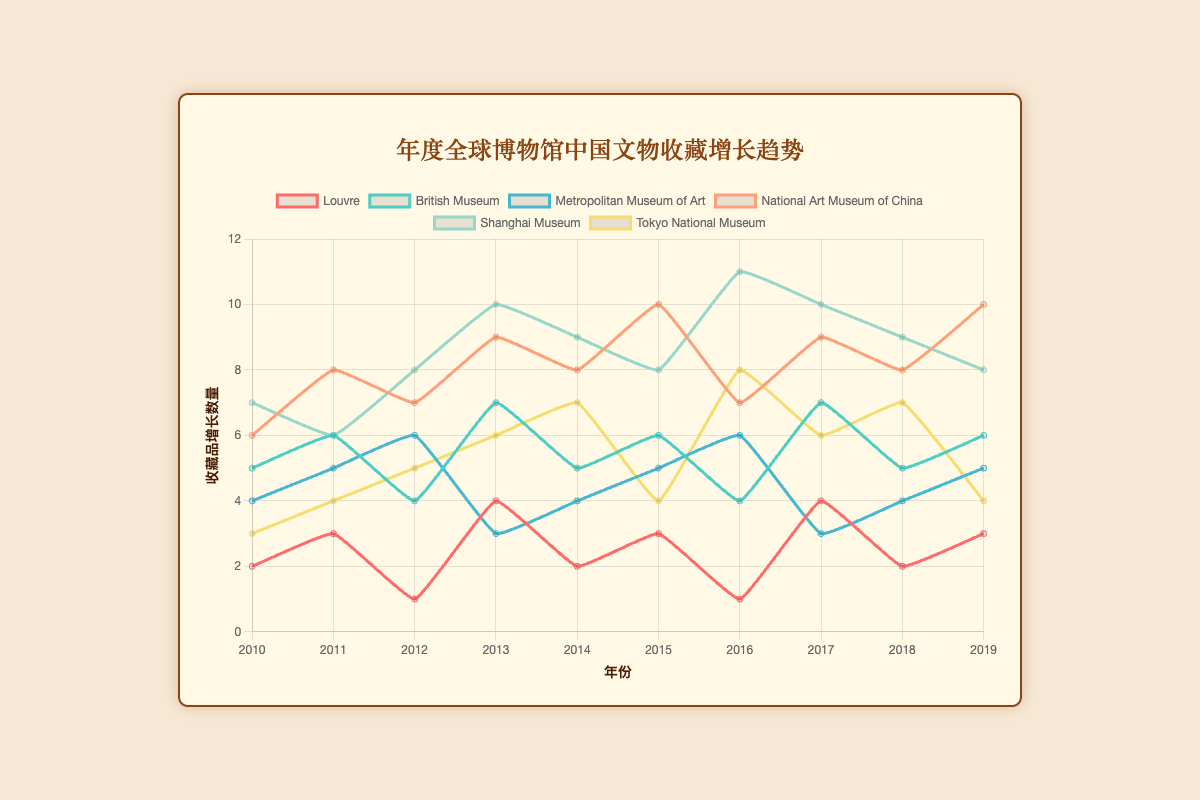Which museum had the highest number of acquisitions in 2010? Look for the data corresponding to the year 2010 and identify the museum with the highest value. The National Art Museum of China had 6 acquisitions.
Answer: National Art Museum of China How did the acquisitions at the Louvre change from 2010 to 2019? Compare the acquisition values for the Louvre in 2010 and 2019. In 2010 there were 2 acquisitions, and in 2019 there were 3 acquisitions, indicating an increase of 1 acquisition.
Answer: Increase by 1 Which museum shows the greatest variability in yearly acquisitions from 2010 to 2019? Examine the changes in acquisitions for each museum across the years. The Shanghai Museum fluctuates between 7 and 11 acquisitions, showing significant variability.
Answer: Shanghai Museum Between 2014 and 2015, which museum increased their acquisitions by the largest amount? Compare the acquisition changes for each museum between 2014 and 2015. The National Art Museum of China increased from 8 to 10, an increase of 2 acquisitions, which is the largest increase.
Answer: National Art Museum of China What is the average number of acquisitions for the British Museum over the recorded years? Sum the acquisitions for the British Museum from 2010 to 2019 and divide by the number of years. \( \frac{(5+6+4+7+5+6+4+7+5+6)}{10}=5.5 \)
Answer: 5.5 In 2016, how many more acquisitions did the Shanghai Museum have compared to the Tokyo National Museum? Compare the numbers for both museums in 2016. The Shanghai Museum had 11 and the Tokyo National Museum had 8, a difference of 3 acquisitions.
Answer: 3 Which year did the Metropolitan Museum of Art acquire the least number of Chinese antiquities, and how many were acquired? Identify the year with the lowest value for the Metropolitan Museum of Art. In 2013, there were 3 acquisitions, the lowest over the period.
Answer: 2013, 3 Are there any years where any two museums had an equal number of acquisitions? If so, which museums and which year? Compare all pairs of museums for each year to see if any have equal numbers. The National Art Museum of China and Shanghai Museum both had 8 acquisitions in 2012.
Answer: National Art Museum of China and Shanghai Museum, 2012 